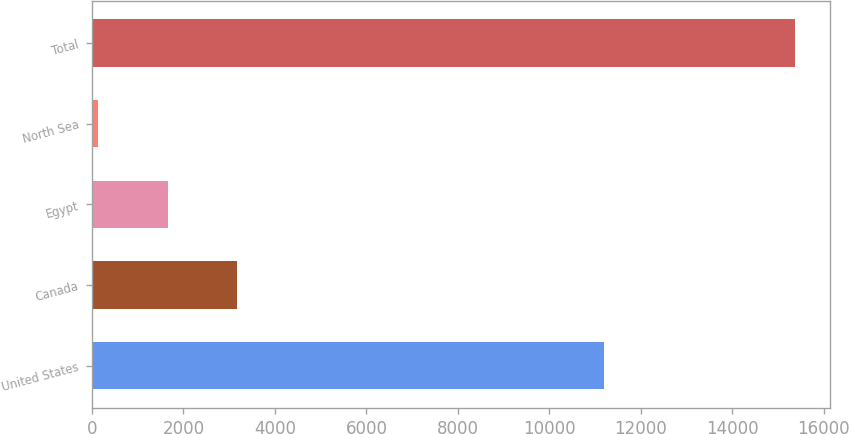Convert chart. <chart><loc_0><loc_0><loc_500><loc_500><bar_chart><fcel>United States<fcel>Canada<fcel>Egypt<fcel>North Sea<fcel>Total<nl><fcel>11185<fcel>3180<fcel>1657.5<fcel>135<fcel>15360<nl></chart> 